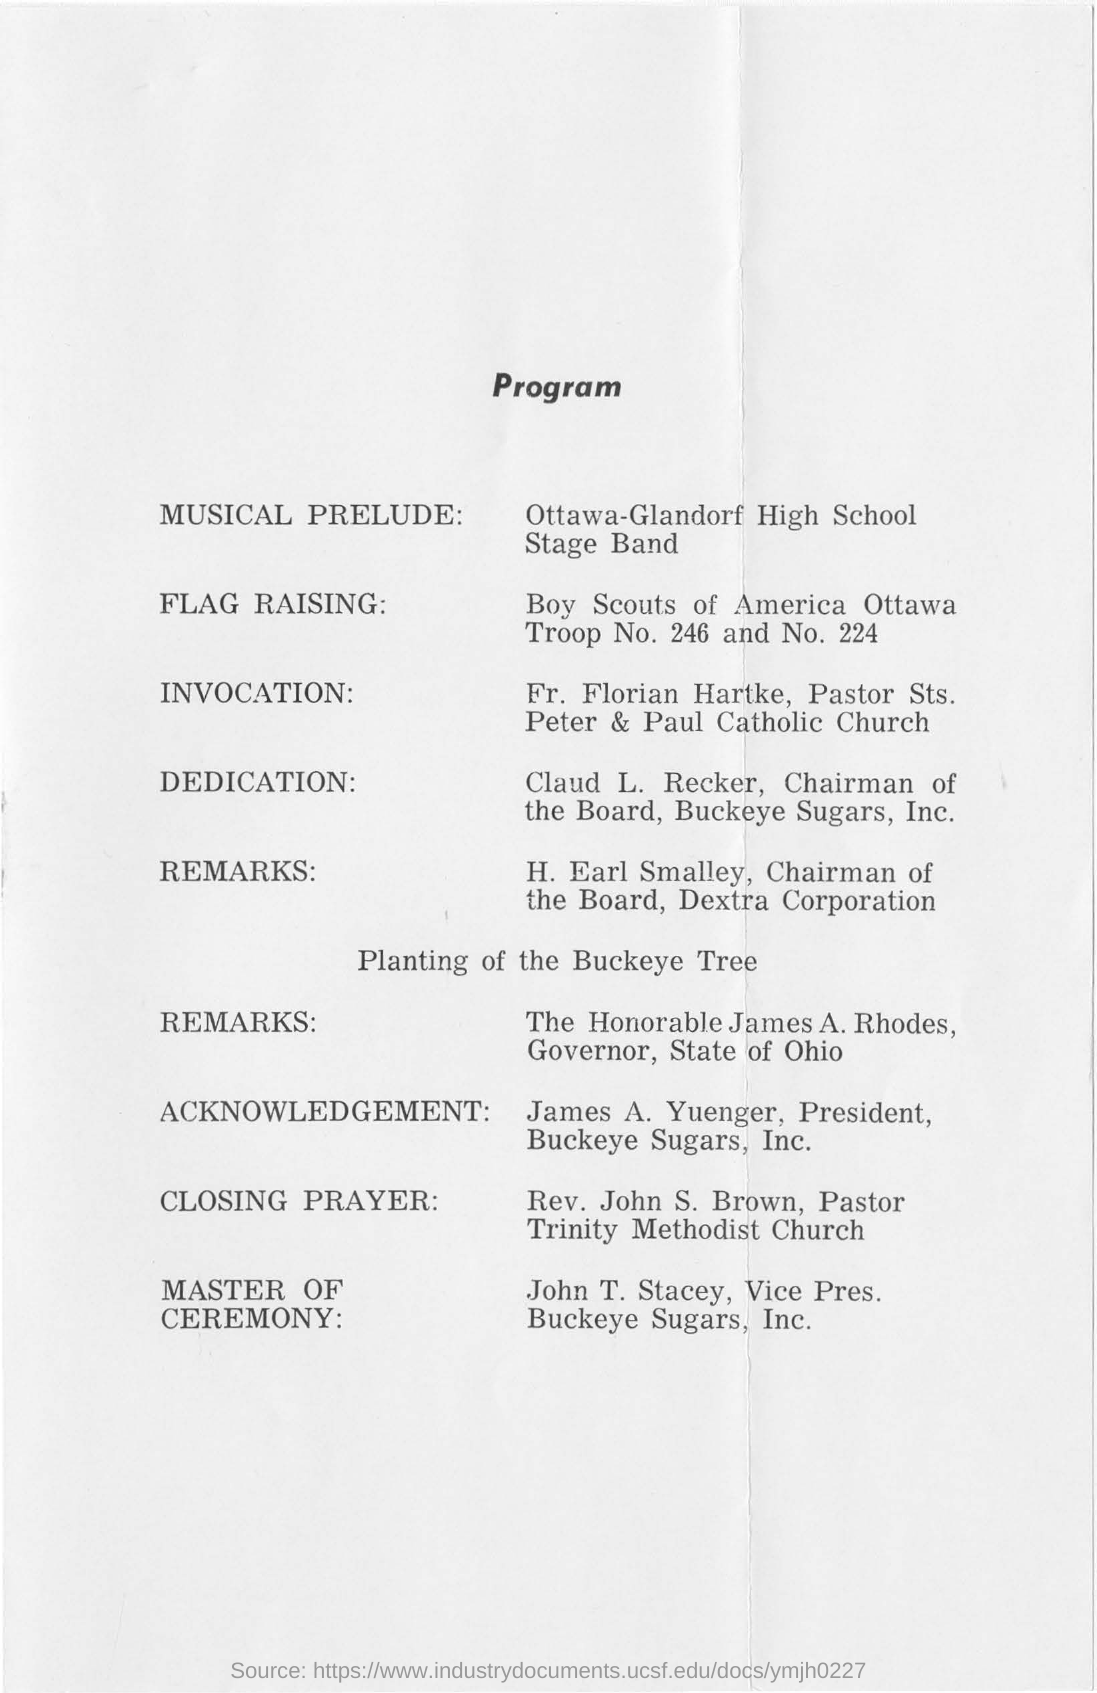Point out several critical features in this image. As per the program schedule, John T. Stacey, Vice President of Buckeye Sugars, Inc., will serve as the Master of Ceremony. The "Musical Prelude" is performed by the Ottawa-Glandorf High School Stage Band. 